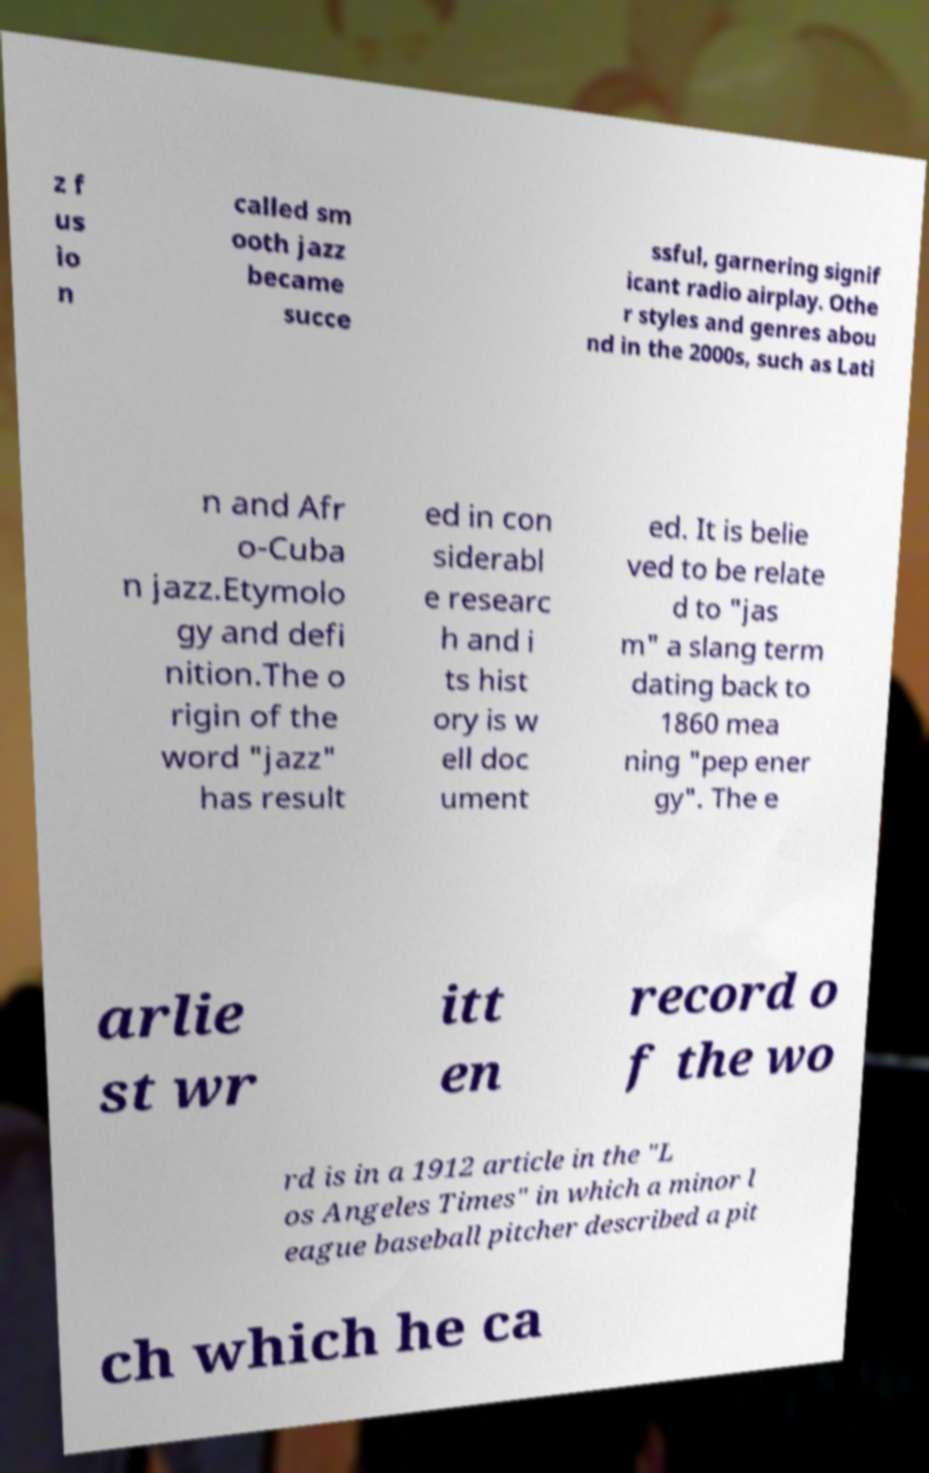Can you accurately transcribe the text from the provided image for me? z f us io n called sm ooth jazz became succe ssful, garnering signif icant radio airplay. Othe r styles and genres abou nd in the 2000s, such as Lati n and Afr o-Cuba n jazz.Etymolo gy and defi nition.The o rigin of the word "jazz" has result ed in con siderabl e researc h and i ts hist ory is w ell doc ument ed. It is belie ved to be relate d to "jas m" a slang term dating back to 1860 mea ning "pep ener gy". The e arlie st wr itt en record o f the wo rd is in a 1912 article in the "L os Angeles Times" in which a minor l eague baseball pitcher described a pit ch which he ca 